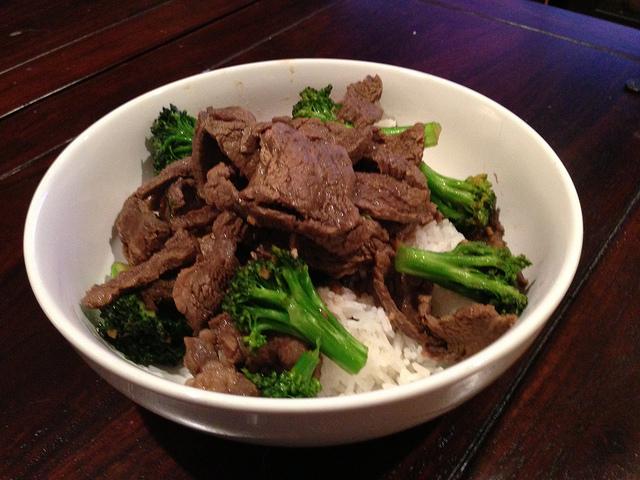What kind of food is shown?
Short answer required. Asian. What type of meat is shown?
Quick response, please. Beef. How was the meal prepared?
Be succinct. Steamed. What type of meat is this?
Be succinct. Beef. 